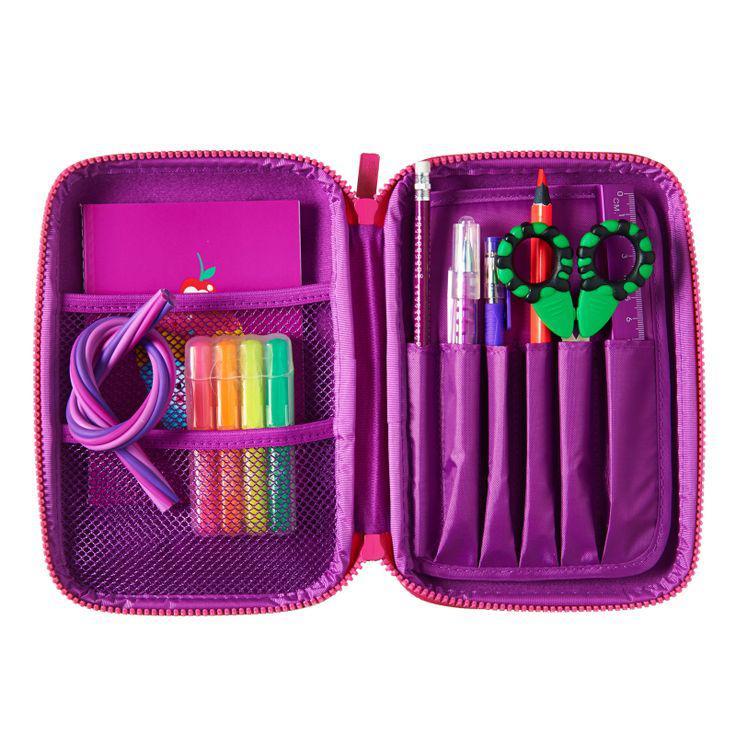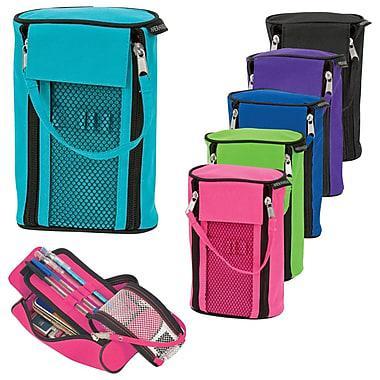The first image is the image on the left, the second image is the image on the right. Analyze the images presented: Is the assertion "Each image includes a closed zipper case to the right of an open, filled pencil case." valid? Answer yes or no. No. The first image is the image on the left, the second image is the image on the right. Assess this claim about the two images: "There are no more than two camera pencil toppers in both sets of images.". Correct or not? Answer yes or no. No. 